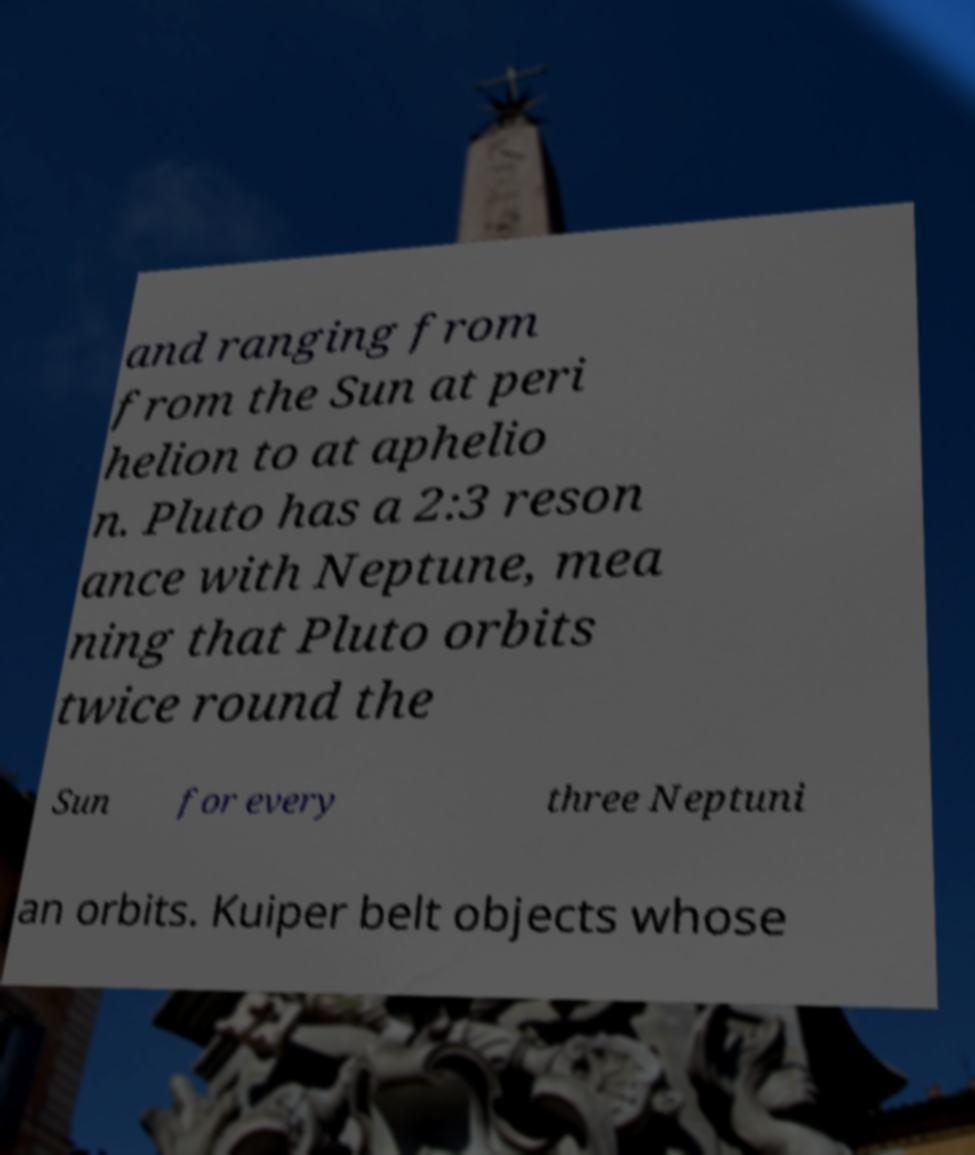Could you assist in decoding the text presented in this image and type it out clearly? and ranging from from the Sun at peri helion to at aphelio n. Pluto has a 2:3 reson ance with Neptune, mea ning that Pluto orbits twice round the Sun for every three Neptuni an orbits. Kuiper belt objects whose 